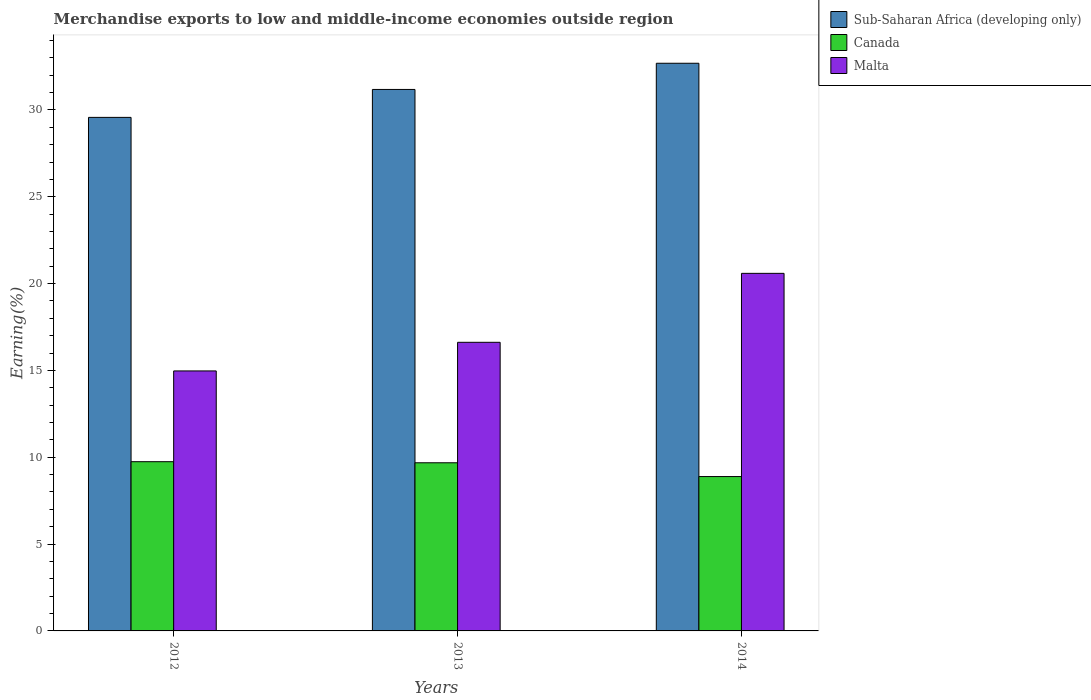Are the number of bars per tick equal to the number of legend labels?
Keep it short and to the point. Yes. Are the number of bars on each tick of the X-axis equal?
Make the answer very short. Yes. What is the label of the 2nd group of bars from the left?
Your response must be concise. 2013. What is the percentage of amount earned from merchandise exports in Malta in 2013?
Provide a succinct answer. 16.62. Across all years, what is the maximum percentage of amount earned from merchandise exports in Sub-Saharan Africa (developing only)?
Your answer should be very brief. 32.69. Across all years, what is the minimum percentage of amount earned from merchandise exports in Canada?
Give a very brief answer. 8.89. What is the total percentage of amount earned from merchandise exports in Malta in the graph?
Your response must be concise. 52.18. What is the difference between the percentage of amount earned from merchandise exports in Malta in 2012 and that in 2013?
Ensure brevity in your answer.  -1.65. What is the difference between the percentage of amount earned from merchandise exports in Malta in 2012 and the percentage of amount earned from merchandise exports in Sub-Saharan Africa (developing only) in 2013?
Keep it short and to the point. -16.21. What is the average percentage of amount earned from merchandise exports in Malta per year?
Ensure brevity in your answer.  17.39. In the year 2014, what is the difference between the percentage of amount earned from merchandise exports in Malta and percentage of amount earned from merchandise exports in Canada?
Your answer should be very brief. 11.7. In how many years, is the percentage of amount earned from merchandise exports in Canada greater than 21 %?
Ensure brevity in your answer.  0. What is the ratio of the percentage of amount earned from merchandise exports in Malta in 2013 to that in 2014?
Make the answer very short. 0.81. What is the difference between the highest and the second highest percentage of amount earned from merchandise exports in Malta?
Ensure brevity in your answer.  3.97. What is the difference between the highest and the lowest percentage of amount earned from merchandise exports in Canada?
Give a very brief answer. 0.86. In how many years, is the percentage of amount earned from merchandise exports in Sub-Saharan Africa (developing only) greater than the average percentage of amount earned from merchandise exports in Sub-Saharan Africa (developing only) taken over all years?
Ensure brevity in your answer.  2. What does the 3rd bar from the left in 2013 represents?
Make the answer very short. Malta. What does the 3rd bar from the right in 2013 represents?
Keep it short and to the point. Sub-Saharan Africa (developing only). Is it the case that in every year, the sum of the percentage of amount earned from merchandise exports in Canada and percentage of amount earned from merchandise exports in Malta is greater than the percentage of amount earned from merchandise exports in Sub-Saharan Africa (developing only)?
Your response must be concise. No. How many years are there in the graph?
Provide a succinct answer. 3. Are the values on the major ticks of Y-axis written in scientific E-notation?
Provide a succinct answer. No. Does the graph contain any zero values?
Your response must be concise. No. Where does the legend appear in the graph?
Your answer should be compact. Top right. What is the title of the graph?
Provide a succinct answer. Merchandise exports to low and middle-income economies outside region. What is the label or title of the Y-axis?
Offer a terse response. Earning(%). What is the Earning(%) of Sub-Saharan Africa (developing only) in 2012?
Provide a short and direct response. 29.57. What is the Earning(%) in Canada in 2012?
Your answer should be compact. 9.74. What is the Earning(%) in Malta in 2012?
Offer a very short reply. 14.97. What is the Earning(%) in Sub-Saharan Africa (developing only) in 2013?
Give a very brief answer. 31.18. What is the Earning(%) of Canada in 2013?
Provide a short and direct response. 9.68. What is the Earning(%) of Malta in 2013?
Offer a terse response. 16.62. What is the Earning(%) of Sub-Saharan Africa (developing only) in 2014?
Provide a succinct answer. 32.69. What is the Earning(%) in Canada in 2014?
Keep it short and to the point. 8.89. What is the Earning(%) of Malta in 2014?
Keep it short and to the point. 20.59. Across all years, what is the maximum Earning(%) of Sub-Saharan Africa (developing only)?
Provide a short and direct response. 32.69. Across all years, what is the maximum Earning(%) in Canada?
Offer a terse response. 9.74. Across all years, what is the maximum Earning(%) of Malta?
Give a very brief answer. 20.59. Across all years, what is the minimum Earning(%) in Sub-Saharan Africa (developing only)?
Offer a very short reply. 29.57. Across all years, what is the minimum Earning(%) in Canada?
Offer a very short reply. 8.89. Across all years, what is the minimum Earning(%) in Malta?
Provide a succinct answer. 14.97. What is the total Earning(%) in Sub-Saharan Africa (developing only) in the graph?
Offer a terse response. 93.44. What is the total Earning(%) in Canada in the graph?
Make the answer very short. 28.31. What is the total Earning(%) in Malta in the graph?
Make the answer very short. 52.18. What is the difference between the Earning(%) of Sub-Saharan Africa (developing only) in 2012 and that in 2013?
Ensure brevity in your answer.  -1.61. What is the difference between the Earning(%) in Canada in 2012 and that in 2013?
Provide a succinct answer. 0.06. What is the difference between the Earning(%) in Malta in 2012 and that in 2013?
Your answer should be compact. -1.65. What is the difference between the Earning(%) of Sub-Saharan Africa (developing only) in 2012 and that in 2014?
Offer a very short reply. -3.12. What is the difference between the Earning(%) of Canada in 2012 and that in 2014?
Ensure brevity in your answer.  0.86. What is the difference between the Earning(%) in Malta in 2012 and that in 2014?
Keep it short and to the point. -5.62. What is the difference between the Earning(%) of Sub-Saharan Africa (developing only) in 2013 and that in 2014?
Ensure brevity in your answer.  -1.51. What is the difference between the Earning(%) in Canada in 2013 and that in 2014?
Provide a short and direct response. 0.79. What is the difference between the Earning(%) in Malta in 2013 and that in 2014?
Offer a terse response. -3.97. What is the difference between the Earning(%) of Sub-Saharan Africa (developing only) in 2012 and the Earning(%) of Canada in 2013?
Your answer should be very brief. 19.89. What is the difference between the Earning(%) of Sub-Saharan Africa (developing only) in 2012 and the Earning(%) of Malta in 2013?
Your response must be concise. 12.95. What is the difference between the Earning(%) of Canada in 2012 and the Earning(%) of Malta in 2013?
Your response must be concise. -6.88. What is the difference between the Earning(%) of Sub-Saharan Africa (developing only) in 2012 and the Earning(%) of Canada in 2014?
Give a very brief answer. 20.68. What is the difference between the Earning(%) of Sub-Saharan Africa (developing only) in 2012 and the Earning(%) of Malta in 2014?
Offer a very short reply. 8.98. What is the difference between the Earning(%) of Canada in 2012 and the Earning(%) of Malta in 2014?
Your response must be concise. -10.85. What is the difference between the Earning(%) in Sub-Saharan Africa (developing only) in 2013 and the Earning(%) in Canada in 2014?
Ensure brevity in your answer.  22.29. What is the difference between the Earning(%) of Sub-Saharan Africa (developing only) in 2013 and the Earning(%) of Malta in 2014?
Offer a very short reply. 10.59. What is the difference between the Earning(%) in Canada in 2013 and the Earning(%) in Malta in 2014?
Your answer should be very brief. -10.91. What is the average Earning(%) in Sub-Saharan Africa (developing only) per year?
Your answer should be very brief. 31.15. What is the average Earning(%) in Canada per year?
Provide a succinct answer. 9.44. What is the average Earning(%) in Malta per year?
Provide a short and direct response. 17.39. In the year 2012, what is the difference between the Earning(%) of Sub-Saharan Africa (developing only) and Earning(%) of Canada?
Keep it short and to the point. 19.83. In the year 2012, what is the difference between the Earning(%) in Sub-Saharan Africa (developing only) and Earning(%) in Malta?
Provide a succinct answer. 14.6. In the year 2012, what is the difference between the Earning(%) in Canada and Earning(%) in Malta?
Give a very brief answer. -5.23. In the year 2013, what is the difference between the Earning(%) of Sub-Saharan Africa (developing only) and Earning(%) of Canada?
Provide a succinct answer. 21.5. In the year 2013, what is the difference between the Earning(%) in Sub-Saharan Africa (developing only) and Earning(%) in Malta?
Your response must be concise. 14.56. In the year 2013, what is the difference between the Earning(%) in Canada and Earning(%) in Malta?
Ensure brevity in your answer.  -6.94. In the year 2014, what is the difference between the Earning(%) in Sub-Saharan Africa (developing only) and Earning(%) in Canada?
Offer a very short reply. 23.8. In the year 2014, what is the difference between the Earning(%) in Sub-Saharan Africa (developing only) and Earning(%) in Malta?
Offer a terse response. 12.1. In the year 2014, what is the difference between the Earning(%) of Canada and Earning(%) of Malta?
Offer a terse response. -11.7. What is the ratio of the Earning(%) of Sub-Saharan Africa (developing only) in 2012 to that in 2013?
Make the answer very short. 0.95. What is the ratio of the Earning(%) of Canada in 2012 to that in 2013?
Offer a terse response. 1.01. What is the ratio of the Earning(%) in Malta in 2012 to that in 2013?
Give a very brief answer. 0.9. What is the ratio of the Earning(%) of Sub-Saharan Africa (developing only) in 2012 to that in 2014?
Keep it short and to the point. 0.9. What is the ratio of the Earning(%) in Canada in 2012 to that in 2014?
Offer a terse response. 1.1. What is the ratio of the Earning(%) in Malta in 2012 to that in 2014?
Your answer should be very brief. 0.73. What is the ratio of the Earning(%) in Sub-Saharan Africa (developing only) in 2013 to that in 2014?
Make the answer very short. 0.95. What is the ratio of the Earning(%) in Canada in 2013 to that in 2014?
Give a very brief answer. 1.09. What is the ratio of the Earning(%) of Malta in 2013 to that in 2014?
Offer a terse response. 0.81. What is the difference between the highest and the second highest Earning(%) in Sub-Saharan Africa (developing only)?
Provide a short and direct response. 1.51. What is the difference between the highest and the second highest Earning(%) in Canada?
Ensure brevity in your answer.  0.06. What is the difference between the highest and the second highest Earning(%) in Malta?
Provide a short and direct response. 3.97. What is the difference between the highest and the lowest Earning(%) in Sub-Saharan Africa (developing only)?
Provide a short and direct response. 3.12. What is the difference between the highest and the lowest Earning(%) in Canada?
Your answer should be compact. 0.86. What is the difference between the highest and the lowest Earning(%) in Malta?
Provide a succinct answer. 5.62. 